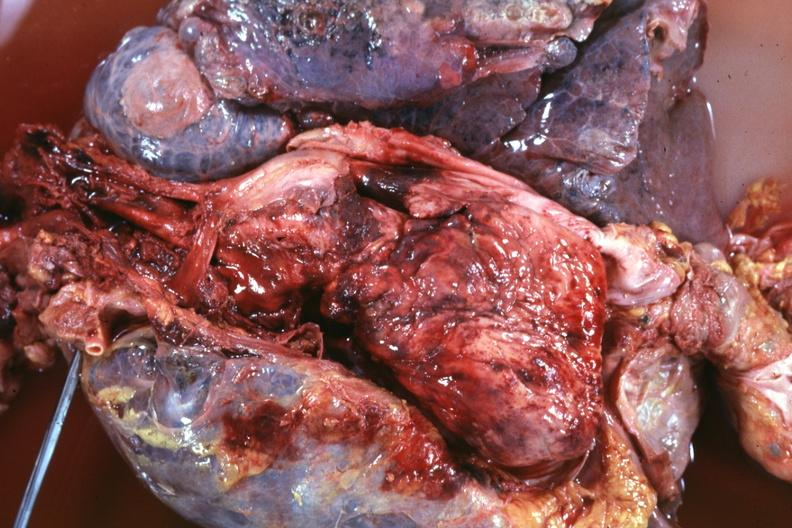what does this image show?
Answer the question using a single word or phrase. Thoracic organs dissected to show super cava and region of tumor invasion quite good 